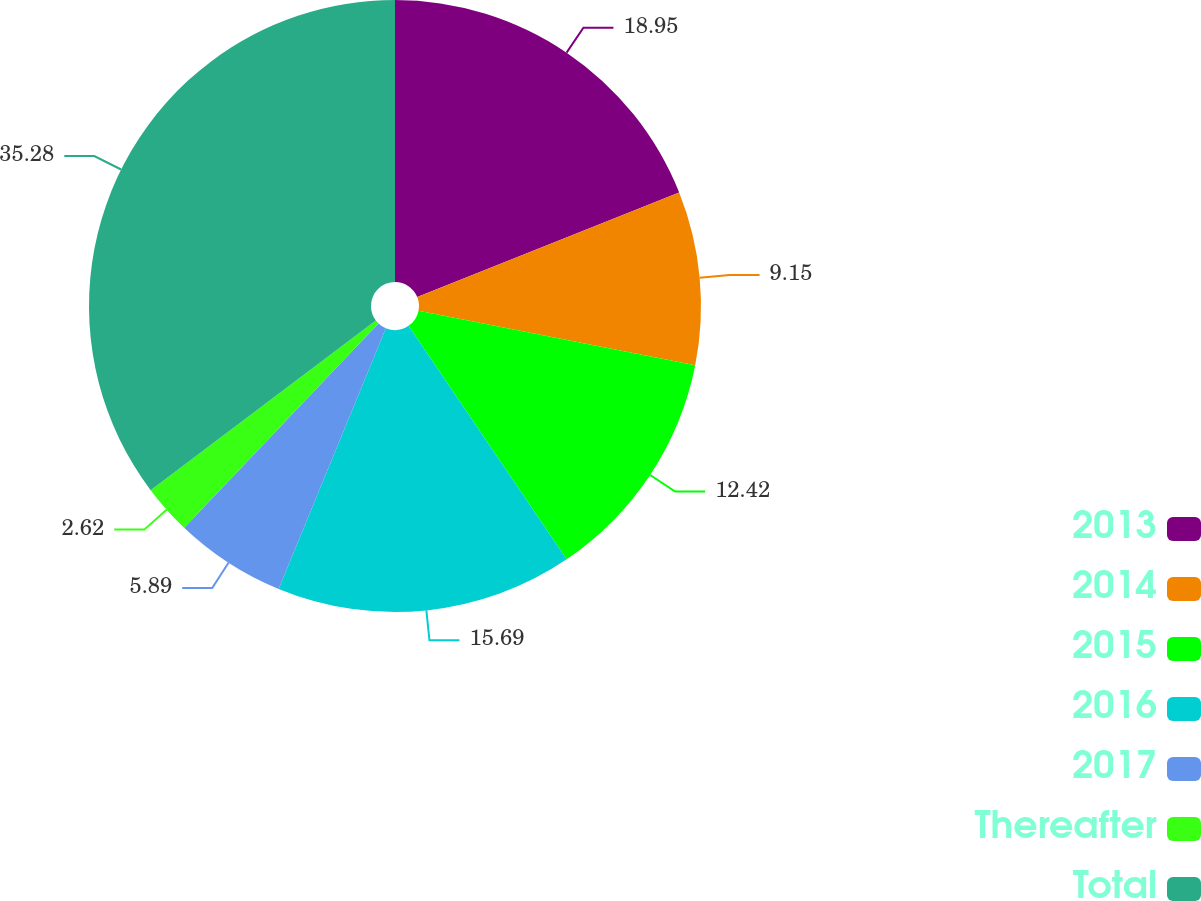Convert chart. <chart><loc_0><loc_0><loc_500><loc_500><pie_chart><fcel>2013<fcel>2014<fcel>2015<fcel>2016<fcel>2017<fcel>Thereafter<fcel>Total<nl><fcel>18.95%<fcel>9.15%<fcel>12.42%<fcel>15.69%<fcel>5.89%<fcel>2.62%<fcel>35.28%<nl></chart> 